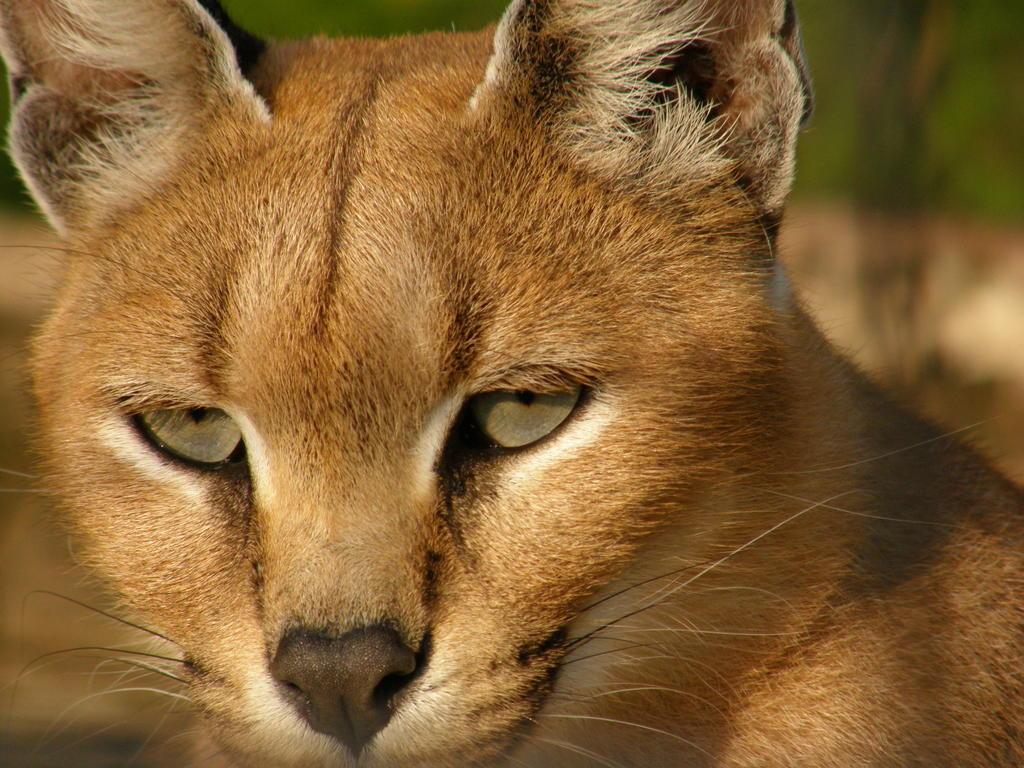How would you summarize this image in a sentence or two? In this image, I can see the face of the wild cat, which is named as caracal. The background looks blurry. 